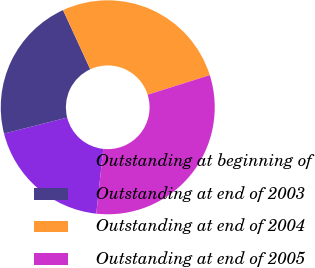<chart> <loc_0><loc_0><loc_500><loc_500><pie_chart><fcel>Outstanding at beginning of<fcel>Outstanding at end of 2003<fcel>Outstanding at end of 2004<fcel>Outstanding at end of 2005<nl><fcel>19.34%<fcel>22.09%<fcel>27.0%<fcel>31.56%<nl></chart> 